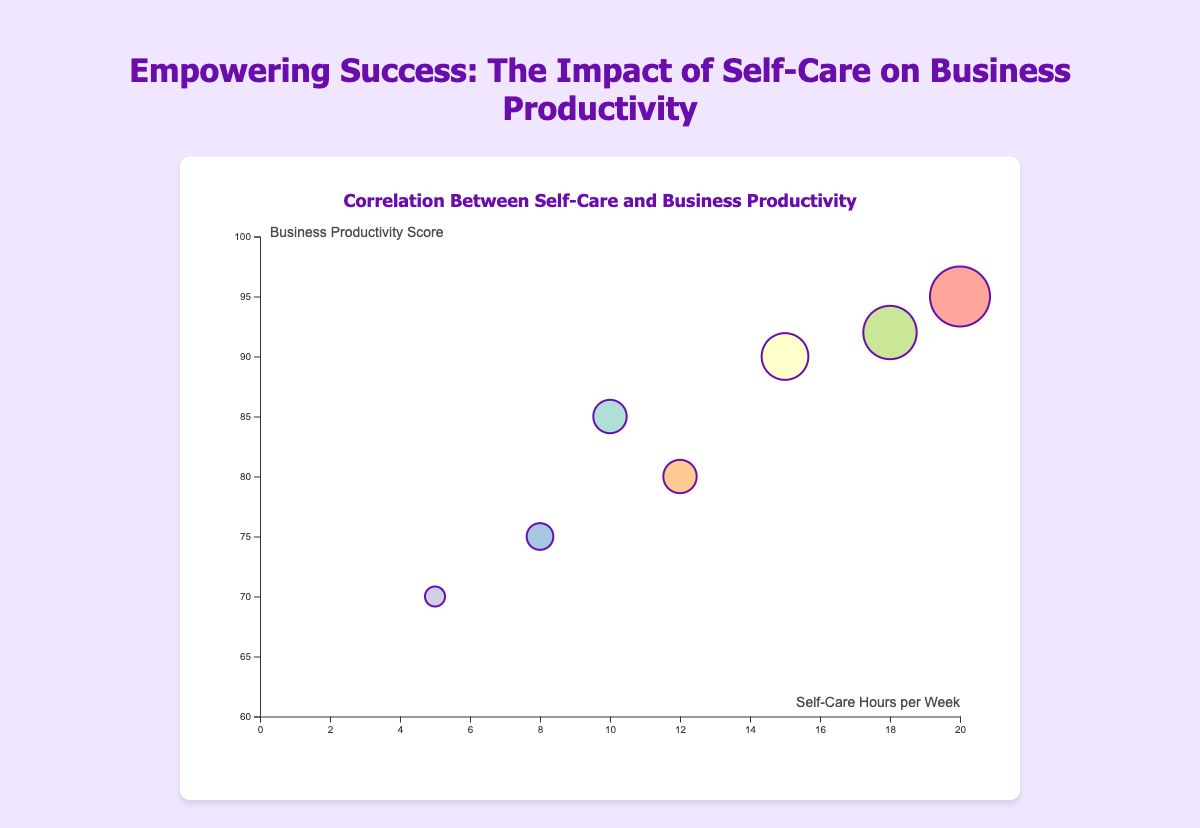What is the title of the chart? The title of the chart is clearly indicated at the top of the figure.
Answer: Empowering Success: The Impact of Self-Care on Business Productivity How many data points are represented in the chart? Counting the number of bubbles in the chart gives the number of data points.
Answer: 7 Who spends the most hours per week on self-care? The person with the highest value on the horizontal axis (Self-Care Hours per Week) represents who spends the most hours.
Answer: Fatima Khan Which entrepreneur has the highest business productivity score? The entrepreneur with the highest value on the vertical axis (Business Productivity Score) represents the highest productivity.
Answer: Fatima Khan Which entrepreneur has the smallest bubble size? The bubble size is visualized by the radius of the circles, and the smallest bubble corresponds to the smallest radius.
Answer: Linda Lee What are the average self-care hours per week among all entrepreneurs? Sum all self-care hours and divide by the number of entrepreneurs: (10 + 15 + 5 + 20 + 8 + 12 + 18) / 7 = 12.57
Answer: 12.57 What is the range of business productivity scores among the entrepreneurs? Subtract the smallest productivity score from the largest: 95 (Fatima Khan) - 70 (Linda Lee) = 25
Answer: 25 Compare the business productivity score of Maria Sanchez and Chloe Brown. Locate the business productivity scores on the vertical axis for both entrepreneurs. Sanchez has 90, and Brown has 75, so Maria Sanchez's score is higher.
Answer: Maria Sanchez What is the bubble color assigned to Alice Johnson? Each bubble's color corresponds to a specific entrepreneur, and Alice Johnson’s bubble color can be visually identified on the chart.
Answer: Varying answer (depending on actual color) How does the self-care time correlate with business productivity scores based on the visualization? Examine the general trend of the bubbles from left to right and from bottom to top. A positive correlation is identified if higher self-care hours generally associate with higher productivity scores.
Answer: Positive correlation 